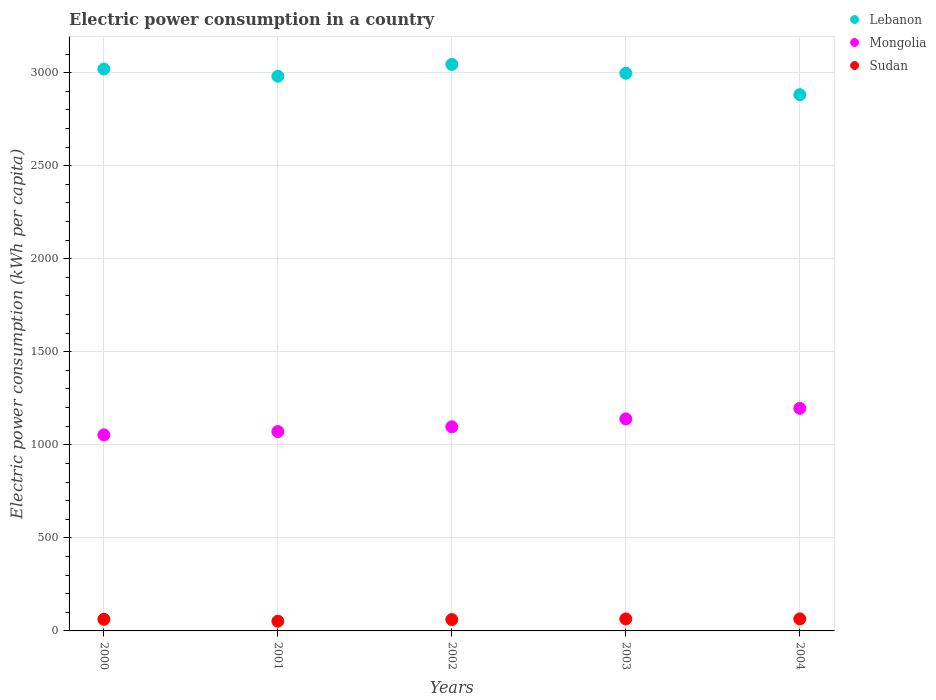How many different coloured dotlines are there?
Ensure brevity in your answer.  3. Is the number of dotlines equal to the number of legend labels?
Your answer should be compact. Yes. What is the electric power consumption in in Lebanon in 2001?
Make the answer very short. 2980.47. Across all years, what is the maximum electric power consumption in in Lebanon?
Give a very brief answer. 3044.13. Across all years, what is the minimum electric power consumption in in Sudan?
Your answer should be very brief. 52.22. What is the total electric power consumption in in Sudan in the graph?
Ensure brevity in your answer.  304.32. What is the difference between the electric power consumption in in Mongolia in 2003 and that in 2004?
Keep it short and to the point. -56.71. What is the difference between the electric power consumption in in Lebanon in 2004 and the electric power consumption in in Mongolia in 2000?
Offer a terse response. 1828.13. What is the average electric power consumption in in Mongolia per year?
Your answer should be compact. 1111.39. In the year 2002, what is the difference between the electric power consumption in in Sudan and electric power consumption in in Mongolia?
Offer a very short reply. -1035.84. In how many years, is the electric power consumption in in Mongolia greater than 2500 kWh per capita?
Ensure brevity in your answer.  0. What is the ratio of the electric power consumption in in Mongolia in 2002 to that in 2003?
Your answer should be very brief. 0.96. Is the electric power consumption in in Lebanon in 2001 less than that in 2003?
Offer a very short reply. Yes. Is the difference between the electric power consumption in in Sudan in 2000 and 2001 greater than the difference between the electric power consumption in in Mongolia in 2000 and 2001?
Offer a terse response. Yes. What is the difference between the highest and the second highest electric power consumption in in Sudan?
Provide a short and direct response. 0.3. What is the difference between the highest and the lowest electric power consumption in in Lebanon?
Keep it short and to the point. 162.38. In how many years, is the electric power consumption in in Mongolia greater than the average electric power consumption in in Mongolia taken over all years?
Your answer should be compact. 2. Is the sum of the electric power consumption in in Lebanon in 2000 and 2001 greater than the maximum electric power consumption in in Mongolia across all years?
Your answer should be compact. Yes. Is it the case that in every year, the sum of the electric power consumption in in Mongolia and electric power consumption in in Sudan  is greater than the electric power consumption in in Lebanon?
Provide a succinct answer. No. How many years are there in the graph?
Your answer should be very brief. 5. Are the values on the major ticks of Y-axis written in scientific E-notation?
Keep it short and to the point. No. Does the graph contain any zero values?
Ensure brevity in your answer.  No. Where does the legend appear in the graph?
Your answer should be compact. Top right. What is the title of the graph?
Offer a terse response. Electric power consumption in a country. What is the label or title of the Y-axis?
Your answer should be very brief. Electric power consumption (kWh per capita). What is the Electric power consumption (kWh per capita) of Lebanon in 2000?
Provide a short and direct response. 3019.43. What is the Electric power consumption (kWh per capita) in Mongolia in 2000?
Your response must be concise. 1053.62. What is the Electric power consumption (kWh per capita) in Sudan in 2000?
Give a very brief answer. 62.41. What is the Electric power consumption (kWh per capita) of Lebanon in 2001?
Your answer should be very brief. 2980.47. What is the Electric power consumption (kWh per capita) in Mongolia in 2001?
Your response must be concise. 1071.19. What is the Electric power consumption (kWh per capita) of Sudan in 2001?
Ensure brevity in your answer.  52.22. What is the Electric power consumption (kWh per capita) of Lebanon in 2002?
Your answer should be compact. 3044.13. What is the Electric power consumption (kWh per capita) of Mongolia in 2002?
Your answer should be compact. 1096.79. What is the Electric power consumption (kWh per capita) of Sudan in 2002?
Your answer should be compact. 60.95. What is the Electric power consumption (kWh per capita) of Lebanon in 2003?
Your answer should be very brief. 2996.65. What is the Electric power consumption (kWh per capita) in Mongolia in 2003?
Keep it short and to the point. 1139.31. What is the Electric power consumption (kWh per capita) of Sudan in 2003?
Make the answer very short. 64.23. What is the Electric power consumption (kWh per capita) in Lebanon in 2004?
Give a very brief answer. 2881.75. What is the Electric power consumption (kWh per capita) of Mongolia in 2004?
Your answer should be compact. 1196.02. What is the Electric power consumption (kWh per capita) in Sudan in 2004?
Offer a terse response. 64.53. Across all years, what is the maximum Electric power consumption (kWh per capita) of Lebanon?
Give a very brief answer. 3044.13. Across all years, what is the maximum Electric power consumption (kWh per capita) in Mongolia?
Make the answer very short. 1196.02. Across all years, what is the maximum Electric power consumption (kWh per capita) in Sudan?
Provide a short and direct response. 64.53. Across all years, what is the minimum Electric power consumption (kWh per capita) in Lebanon?
Offer a very short reply. 2881.75. Across all years, what is the minimum Electric power consumption (kWh per capita) in Mongolia?
Give a very brief answer. 1053.62. Across all years, what is the minimum Electric power consumption (kWh per capita) in Sudan?
Your answer should be compact. 52.22. What is the total Electric power consumption (kWh per capita) in Lebanon in the graph?
Ensure brevity in your answer.  1.49e+04. What is the total Electric power consumption (kWh per capita) of Mongolia in the graph?
Provide a short and direct response. 5556.93. What is the total Electric power consumption (kWh per capita) of Sudan in the graph?
Offer a terse response. 304.32. What is the difference between the Electric power consumption (kWh per capita) of Lebanon in 2000 and that in 2001?
Offer a terse response. 38.96. What is the difference between the Electric power consumption (kWh per capita) in Mongolia in 2000 and that in 2001?
Ensure brevity in your answer.  -17.57. What is the difference between the Electric power consumption (kWh per capita) of Sudan in 2000 and that in 2001?
Offer a very short reply. 10.19. What is the difference between the Electric power consumption (kWh per capita) of Lebanon in 2000 and that in 2002?
Give a very brief answer. -24.7. What is the difference between the Electric power consumption (kWh per capita) of Mongolia in 2000 and that in 2002?
Your response must be concise. -43.16. What is the difference between the Electric power consumption (kWh per capita) in Sudan in 2000 and that in 2002?
Give a very brief answer. 1.46. What is the difference between the Electric power consumption (kWh per capita) in Lebanon in 2000 and that in 2003?
Your response must be concise. 22.78. What is the difference between the Electric power consumption (kWh per capita) of Mongolia in 2000 and that in 2003?
Your answer should be very brief. -85.68. What is the difference between the Electric power consumption (kWh per capita) in Sudan in 2000 and that in 2003?
Provide a succinct answer. -1.82. What is the difference between the Electric power consumption (kWh per capita) of Lebanon in 2000 and that in 2004?
Offer a terse response. 137.67. What is the difference between the Electric power consumption (kWh per capita) of Mongolia in 2000 and that in 2004?
Provide a succinct answer. -142.39. What is the difference between the Electric power consumption (kWh per capita) of Sudan in 2000 and that in 2004?
Your answer should be compact. -2.12. What is the difference between the Electric power consumption (kWh per capita) in Lebanon in 2001 and that in 2002?
Your answer should be compact. -63.67. What is the difference between the Electric power consumption (kWh per capita) of Mongolia in 2001 and that in 2002?
Keep it short and to the point. -25.59. What is the difference between the Electric power consumption (kWh per capita) of Sudan in 2001 and that in 2002?
Give a very brief answer. -8.73. What is the difference between the Electric power consumption (kWh per capita) of Lebanon in 2001 and that in 2003?
Offer a terse response. -16.18. What is the difference between the Electric power consumption (kWh per capita) in Mongolia in 2001 and that in 2003?
Provide a succinct answer. -68.11. What is the difference between the Electric power consumption (kWh per capita) of Sudan in 2001 and that in 2003?
Keep it short and to the point. -12.01. What is the difference between the Electric power consumption (kWh per capita) of Lebanon in 2001 and that in 2004?
Ensure brevity in your answer.  98.71. What is the difference between the Electric power consumption (kWh per capita) in Mongolia in 2001 and that in 2004?
Your response must be concise. -124.82. What is the difference between the Electric power consumption (kWh per capita) of Sudan in 2001 and that in 2004?
Provide a succinct answer. -12.31. What is the difference between the Electric power consumption (kWh per capita) of Lebanon in 2002 and that in 2003?
Make the answer very short. 47.48. What is the difference between the Electric power consumption (kWh per capita) in Mongolia in 2002 and that in 2003?
Your answer should be very brief. -42.52. What is the difference between the Electric power consumption (kWh per capita) of Sudan in 2002 and that in 2003?
Provide a short and direct response. -3.28. What is the difference between the Electric power consumption (kWh per capita) in Lebanon in 2002 and that in 2004?
Keep it short and to the point. 162.38. What is the difference between the Electric power consumption (kWh per capita) of Mongolia in 2002 and that in 2004?
Ensure brevity in your answer.  -99.23. What is the difference between the Electric power consumption (kWh per capita) in Sudan in 2002 and that in 2004?
Provide a short and direct response. -3.58. What is the difference between the Electric power consumption (kWh per capita) of Lebanon in 2003 and that in 2004?
Your answer should be very brief. 114.9. What is the difference between the Electric power consumption (kWh per capita) in Mongolia in 2003 and that in 2004?
Keep it short and to the point. -56.71. What is the difference between the Electric power consumption (kWh per capita) in Sudan in 2003 and that in 2004?
Keep it short and to the point. -0.3. What is the difference between the Electric power consumption (kWh per capita) in Lebanon in 2000 and the Electric power consumption (kWh per capita) in Mongolia in 2001?
Your answer should be compact. 1948.23. What is the difference between the Electric power consumption (kWh per capita) in Lebanon in 2000 and the Electric power consumption (kWh per capita) in Sudan in 2001?
Give a very brief answer. 2967.21. What is the difference between the Electric power consumption (kWh per capita) in Mongolia in 2000 and the Electric power consumption (kWh per capita) in Sudan in 2001?
Offer a very short reply. 1001.41. What is the difference between the Electric power consumption (kWh per capita) of Lebanon in 2000 and the Electric power consumption (kWh per capita) of Mongolia in 2002?
Give a very brief answer. 1922.64. What is the difference between the Electric power consumption (kWh per capita) of Lebanon in 2000 and the Electric power consumption (kWh per capita) of Sudan in 2002?
Your response must be concise. 2958.48. What is the difference between the Electric power consumption (kWh per capita) of Mongolia in 2000 and the Electric power consumption (kWh per capita) of Sudan in 2002?
Make the answer very short. 992.68. What is the difference between the Electric power consumption (kWh per capita) of Lebanon in 2000 and the Electric power consumption (kWh per capita) of Mongolia in 2003?
Your response must be concise. 1880.12. What is the difference between the Electric power consumption (kWh per capita) of Lebanon in 2000 and the Electric power consumption (kWh per capita) of Sudan in 2003?
Your answer should be compact. 2955.2. What is the difference between the Electric power consumption (kWh per capita) of Mongolia in 2000 and the Electric power consumption (kWh per capita) of Sudan in 2003?
Ensure brevity in your answer.  989.4. What is the difference between the Electric power consumption (kWh per capita) in Lebanon in 2000 and the Electric power consumption (kWh per capita) in Mongolia in 2004?
Your answer should be compact. 1823.41. What is the difference between the Electric power consumption (kWh per capita) of Lebanon in 2000 and the Electric power consumption (kWh per capita) of Sudan in 2004?
Keep it short and to the point. 2954.9. What is the difference between the Electric power consumption (kWh per capita) in Mongolia in 2000 and the Electric power consumption (kWh per capita) in Sudan in 2004?
Make the answer very short. 989.1. What is the difference between the Electric power consumption (kWh per capita) of Lebanon in 2001 and the Electric power consumption (kWh per capita) of Mongolia in 2002?
Provide a short and direct response. 1883.68. What is the difference between the Electric power consumption (kWh per capita) in Lebanon in 2001 and the Electric power consumption (kWh per capita) in Sudan in 2002?
Your answer should be compact. 2919.52. What is the difference between the Electric power consumption (kWh per capita) of Mongolia in 2001 and the Electric power consumption (kWh per capita) of Sudan in 2002?
Ensure brevity in your answer.  1010.25. What is the difference between the Electric power consumption (kWh per capita) in Lebanon in 2001 and the Electric power consumption (kWh per capita) in Mongolia in 2003?
Your answer should be very brief. 1841.16. What is the difference between the Electric power consumption (kWh per capita) in Lebanon in 2001 and the Electric power consumption (kWh per capita) in Sudan in 2003?
Offer a very short reply. 2916.24. What is the difference between the Electric power consumption (kWh per capita) of Mongolia in 2001 and the Electric power consumption (kWh per capita) of Sudan in 2003?
Your response must be concise. 1006.97. What is the difference between the Electric power consumption (kWh per capita) of Lebanon in 2001 and the Electric power consumption (kWh per capita) of Mongolia in 2004?
Your answer should be compact. 1784.45. What is the difference between the Electric power consumption (kWh per capita) in Lebanon in 2001 and the Electric power consumption (kWh per capita) in Sudan in 2004?
Your answer should be compact. 2915.94. What is the difference between the Electric power consumption (kWh per capita) of Mongolia in 2001 and the Electric power consumption (kWh per capita) of Sudan in 2004?
Keep it short and to the point. 1006.67. What is the difference between the Electric power consumption (kWh per capita) of Lebanon in 2002 and the Electric power consumption (kWh per capita) of Mongolia in 2003?
Give a very brief answer. 1904.83. What is the difference between the Electric power consumption (kWh per capita) of Lebanon in 2002 and the Electric power consumption (kWh per capita) of Sudan in 2003?
Offer a terse response. 2979.91. What is the difference between the Electric power consumption (kWh per capita) of Mongolia in 2002 and the Electric power consumption (kWh per capita) of Sudan in 2003?
Offer a very short reply. 1032.56. What is the difference between the Electric power consumption (kWh per capita) of Lebanon in 2002 and the Electric power consumption (kWh per capita) of Mongolia in 2004?
Provide a succinct answer. 1848.12. What is the difference between the Electric power consumption (kWh per capita) of Lebanon in 2002 and the Electric power consumption (kWh per capita) of Sudan in 2004?
Provide a succinct answer. 2979.61. What is the difference between the Electric power consumption (kWh per capita) of Mongolia in 2002 and the Electric power consumption (kWh per capita) of Sudan in 2004?
Your answer should be very brief. 1032.26. What is the difference between the Electric power consumption (kWh per capita) of Lebanon in 2003 and the Electric power consumption (kWh per capita) of Mongolia in 2004?
Ensure brevity in your answer.  1800.64. What is the difference between the Electric power consumption (kWh per capita) in Lebanon in 2003 and the Electric power consumption (kWh per capita) in Sudan in 2004?
Provide a succinct answer. 2932.13. What is the difference between the Electric power consumption (kWh per capita) in Mongolia in 2003 and the Electric power consumption (kWh per capita) in Sudan in 2004?
Offer a terse response. 1074.78. What is the average Electric power consumption (kWh per capita) in Lebanon per year?
Give a very brief answer. 2984.49. What is the average Electric power consumption (kWh per capita) in Mongolia per year?
Your answer should be compact. 1111.39. What is the average Electric power consumption (kWh per capita) in Sudan per year?
Give a very brief answer. 60.86. In the year 2000, what is the difference between the Electric power consumption (kWh per capita) of Lebanon and Electric power consumption (kWh per capita) of Mongolia?
Your response must be concise. 1965.8. In the year 2000, what is the difference between the Electric power consumption (kWh per capita) in Lebanon and Electric power consumption (kWh per capita) in Sudan?
Ensure brevity in your answer.  2957.02. In the year 2000, what is the difference between the Electric power consumption (kWh per capita) of Mongolia and Electric power consumption (kWh per capita) of Sudan?
Give a very brief answer. 991.22. In the year 2001, what is the difference between the Electric power consumption (kWh per capita) in Lebanon and Electric power consumption (kWh per capita) in Mongolia?
Provide a short and direct response. 1909.27. In the year 2001, what is the difference between the Electric power consumption (kWh per capita) in Lebanon and Electric power consumption (kWh per capita) in Sudan?
Your answer should be very brief. 2928.25. In the year 2001, what is the difference between the Electric power consumption (kWh per capita) of Mongolia and Electric power consumption (kWh per capita) of Sudan?
Keep it short and to the point. 1018.98. In the year 2002, what is the difference between the Electric power consumption (kWh per capita) in Lebanon and Electric power consumption (kWh per capita) in Mongolia?
Your response must be concise. 1947.35. In the year 2002, what is the difference between the Electric power consumption (kWh per capita) of Lebanon and Electric power consumption (kWh per capita) of Sudan?
Offer a terse response. 2983.19. In the year 2002, what is the difference between the Electric power consumption (kWh per capita) of Mongolia and Electric power consumption (kWh per capita) of Sudan?
Provide a succinct answer. 1035.84. In the year 2003, what is the difference between the Electric power consumption (kWh per capita) in Lebanon and Electric power consumption (kWh per capita) in Mongolia?
Offer a very short reply. 1857.35. In the year 2003, what is the difference between the Electric power consumption (kWh per capita) of Lebanon and Electric power consumption (kWh per capita) of Sudan?
Your answer should be compact. 2932.42. In the year 2003, what is the difference between the Electric power consumption (kWh per capita) of Mongolia and Electric power consumption (kWh per capita) of Sudan?
Keep it short and to the point. 1075.08. In the year 2004, what is the difference between the Electric power consumption (kWh per capita) of Lebanon and Electric power consumption (kWh per capita) of Mongolia?
Your answer should be very brief. 1685.74. In the year 2004, what is the difference between the Electric power consumption (kWh per capita) of Lebanon and Electric power consumption (kWh per capita) of Sudan?
Keep it short and to the point. 2817.23. In the year 2004, what is the difference between the Electric power consumption (kWh per capita) of Mongolia and Electric power consumption (kWh per capita) of Sudan?
Give a very brief answer. 1131.49. What is the ratio of the Electric power consumption (kWh per capita) in Lebanon in 2000 to that in 2001?
Provide a succinct answer. 1.01. What is the ratio of the Electric power consumption (kWh per capita) in Mongolia in 2000 to that in 2001?
Offer a very short reply. 0.98. What is the ratio of the Electric power consumption (kWh per capita) of Sudan in 2000 to that in 2001?
Your answer should be compact. 1.2. What is the ratio of the Electric power consumption (kWh per capita) of Mongolia in 2000 to that in 2002?
Offer a very short reply. 0.96. What is the ratio of the Electric power consumption (kWh per capita) of Sudan in 2000 to that in 2002?
Ensure brevity in your answer.  1.02. What is the ratio of the Electric power consumption (kWh per capita) of Lebanon in 2000 to that in 2003?
Ensure brevity in your answer.  1.01. What is the ratio of the Electric power consumption (kWh per capita) in Mongolia in 2000 to that in 2003?
Your response must be concise. 0.92. What is the ratio of the Electric power consumption (kWh per capita) in Sudan in 2000 to that in 2003?
Provide a succinct answer. 0.97. What is the ratio of the Electric power consumption (kWh per capita) in Lebanon in 2000 to that in 2004?
Give a very brief answer. 1.05. What is the ratio of the Electric power consumption (kWh per capita) of Mongolia in 2000 to that in 2004?
Offer a terse response. 0.88. What is the ratio of the Electric power consumption (kWh per capita) in Sudan in 2000 to that in 2004?
Offer a terse response. 0.97. What is the ratio of the Electric power consumption (kWh per capita) of Lebanon in 2001 to that in 2002?
Offer a terse response. 0.98. What is the ratio of the Electric power consumption (kWh per capita) in Mongolia in 2001 to that in 2002?
Make the answer very short. 0.98. What is the ratio of the Electric power consumption (kWh per capita) of Sudan in 2001 to that in 2002?
Offer a very short reply. 0.86. What is the ratio of the Electric power consumption (kWh per capita) in Lebanon in 2001 to that in 2003?
Your answer should be compact. 0.99. What is the ratio of the Electric power consumption (kWh per capita) in Mongolia in 2001 to that in 2003?
Offer a terse response. 0.94. What is the ratio of the Electric power consumption (kWh per capita) of Sudan in 2001 to that in 2003?
Provide a short and direct response. 0.81. What is the ratio of the Electric power consumption (kWh per capita) in Lebanon in 2001 to that in 2004?
Your answer should be very brief. 1.03. What is the ratio of the Electric power consumption (kWh per capita) in Mongolia in 2001 to that in 2004?
Ensure brevity in your answer.  0.9. What is the ratio of the Electric power consumption (kWh per capita) in Sudan in 2001 to that in 2004?
Offer a very short reply. 0.81. What is the ratio of the Electric power consumption (kWh per capita) in Lebanon in 2002 to that in 2003?
Make the answer very short. 1.02. What is the ratio of the Electric power consumption (kWh per capita) in Mongolia in 2002 to that in 2003?
Your response must be concise. 0.96. What is the ratio of the Electric power consumption (kWh per capita) of Sudan in 2002 to that in 2003?
Keep it short and to the point. 0.95. What is the ratio of the Electric power consumption (kWh per capita) in Lebanon in 2002 to that in 2004?
Offer a terse response. 1.06. What is the ratio of the Electric power consumption (kWh per capita) of Mongolia in 2002 to that in 2004?
Provide a short and direct response. 0.92. What is the ratio of the Electric power consumption (kWh per capita) of Sudan in 2002 to that in 2004?
Provide a short and direct response. 0.94. What is the ratio of the Electric power consumption (kWh per capita) in Lebanon in 2003 to that in 2004?
Make the answer very short. 1.04. What is the ratio of the Electric power consumption (kWh per capita) of Mongolia in 2003 to that in 2004?
Ensure brevity in your answer.  0.95. What is the ratio of the Electric power consumption (kWh per capita) in Sudan in 2003 to that in 2004?
Your answer should be very brief. 1. What is the difference between the highest and the second highest Electric power consumption (kWh per capita) in Lebanon?
Make the answer very short. 24.7. What is the difference between the highest and the second highest Electric power consumption (kWh per capita) in Mongolia?
Your answer should be compact. 56.71. What is the difference between the highest and the second highest Electric power consumption (kWh per capita) in Sudan?
Your answer should be compact. 0.3. What is the difference between the highest and the lowest Electric power consumption (kWh per capita) of Lebanon?
Your answer should be very brief. 162.38. What is the difference between the highest and the lowest Electric power consumption (kWh per capita) in Mongolia?
Keep it short and to the point. 142.39. What is the difference between the highest and the lowest Electric power consumption (kWh per capita) in Sudan?
Your answer should be very brief. 12.31. 